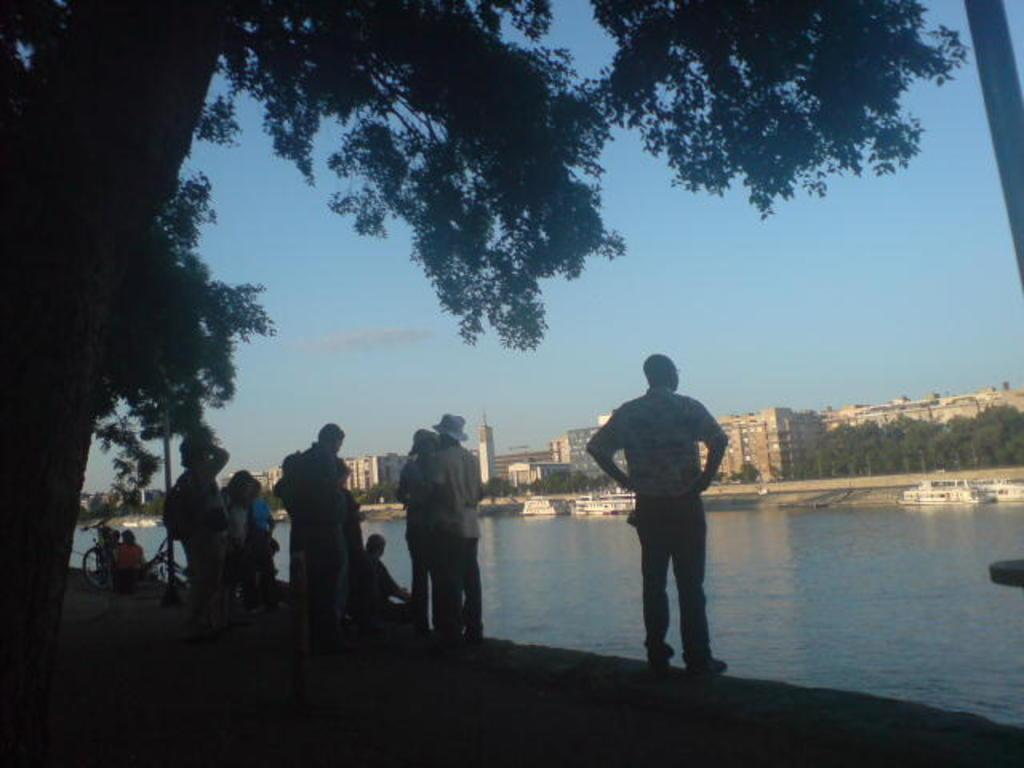How many people are in the image? There are people in the image, but the exact number is not specified. What type of surface can be seen in the image? There is ground visible in the image. What structures are present in the image? There are poles, buildings with windows, and trees in the image. What can be seen moving on the water in the image? There are boats in the image. What is visible above the scene in the image? The sky is visible in the image. What type of dress is the circle wearing in the image? There is no circle or dress present in the image. Is there a notebook visible on the ground in the image? There is no notebook visible on the ground in the image. 